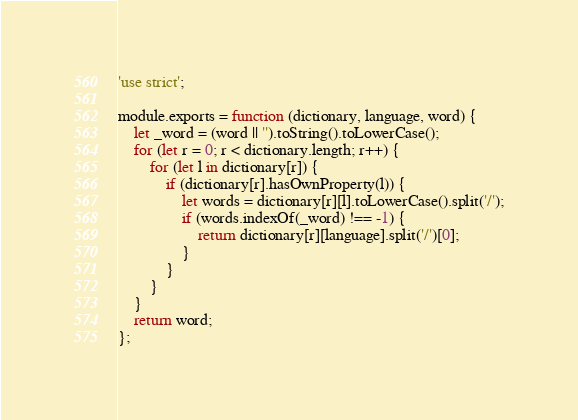Convert code to text. <code><loc_0><loc_0><loc_500><loc_500><_JavaScript_>'use strict';

module.exports = function (dictionary, language, word) {
    let _word = (word || '').toString().toLowerCase();
    for (let r = 0; r < dictionary.length; r++) {
        for (let l in dictionary[r]) {
            if (dictionary[r].hasOwnProperty(l)) {
                let words = dictionary[r][l].toLowerCase().split('/');
                if (words.indexOf(_word) !== -1) {
                    return dictionary[r][language].split('/')[0];
                }
            }
        }
    }
    return word;
};</code> 